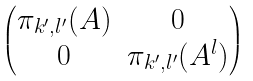Convert formula to latex. <formula><loc_0><loc_0><loc_500><loc_500>\begin{pmatrix} \pi _ { k ^ { \prime } , l ^ { \prime } } ( A ) & 0 \\ 0 & \pi _ { k ^ { \prime } , l ^ { \prime } } ( A ^ { l } ) \end{pmatrix}</formula> 